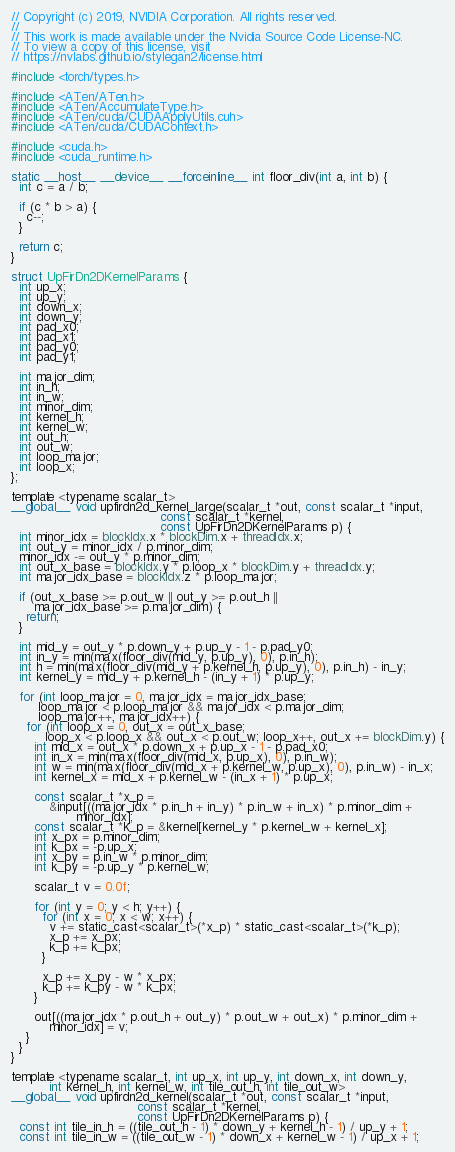Convert code to text. <code><loc_0><loc_0><loc_500><loc_500><_Cuda_>// Copyright (c) 2019, NVIDIA Corporation. All rights reserved.
//
// This work is made available under the Nvidia Source Code License-NC.
// To view a copy of this license, visit
// https://nvlabs.github.io/stylegan2/license.html

#include <torch/types.h>

#include <ATen/ATen.h>
#include <ATen/AccumulateType.h>
#include <ATen/cuda/CUDAApplyUtils.cuh>
#include <ATen/cuda/CUDAContext.h>

#include <cuda.h>
#include <cuda_runtime.h>

static __host__ __device__ __forceinline__ int floor_div(int a, int b) {
  int c = a / b;

  if (c * b > a) {
    c--;
  }

  return c;
}

struct UpFirDn2DKernelParams {
  int up_x;
  int up_y;
  int down_x;
  int down_y;
  int pad_x0;
  int pad_x1;
  int pad_y0;
  int pad_y1;

  int major_dim;
  int in_h;
  int in_w;
  int minor_dim;
  int kernel_h;
  int kernel_w;
  int out_h;
  int out_w;
  int loop_major;
  int loop_x;
};

template <typename scalar_t>
__global__ void upfirdn2d_kernel_large(scalar_t *out, const scalar_t *input,
                                       const scalar_t *kernel,
                                       const UpFirDn2DKernelParams p) {
  int minor_idx = blockIdx.x * blockDim.x + threadIdx.x;
  int out_y = minor_idx / p.minor_dim;
  minor_idx -= out_y * p.minor_dim;
  int out_x_base = blockIdx.y * p.loop_x * blockDim.y + threadIdx.y;
  int major_idx_base = blockIdx.z * p.loop_major;

  if (out_x_base >= p.out_w || out_y >= p.out_h ||
      major_idx_base >= p.major_dim) {
    return;
  }

  int mid_y = out_y * p.down_y + p.up_y - 1 - p.pad_y0;
  int in_y = min(max(floor_div(mid_y, p.up_y), 0), p.in_h);
  int h = min(max(floor_div(mid_y + p.kernel_h, p.up_y), 0), p.in_h) - in_y;
  int kernel_y = mid_y + p.kernel_h - (in_y + 1) * p.up_y;

  for (int loop_major = 0, major_idx = major_idx_base;
       loop_major < p.loop_major && major_idx < p.major_dim;
       loop_major++, major_idx++) {
    for (int loop_x = 0, out_x = out_x_base;
         loop_x < p.loop_x && out_x < p.out_w; loop_x++, out_x += blockDim.y) {
      int mid_x = out_x * p.down_x + p.up_x - 1 - p.pad_x0;
      int in_x = min(max(floor_div(mid_x, p.up_x), 0), p.in_w);
      int w = min(max(floor_div(mid_x + p.kernel_w, p.up_x), 0), p.in_w) - in_x;
      int kernel_x = mid_x + p.kernel_w - (in_x + 1) * p.up_x;

      const scalar_t *x_p =
          &input[((major_idx * p.in_h + in_y) * p.in_w + in_x) * p.minor_dim +
                 minor_idx];
      const scalar_t *k_p = &kernel[kernel_y * p.kernel_w + kernel_x];
      int x_px = p.minor_dim;
      int k_px = -p.up_x;
      int x_py = p.in_w * p.minor_dim;
      int k_py = -p.up_y * p.kernel_w;

      scalar_t v = 0.0f;

      for (int y = 0; y < h; y++) {
        for (int x = 0; x < w; x++) {
          v += static_cast<scalar_t>(*x_p) * static_cast<scalar_t>(*k_p);
          x_p += x_px;
          k_p += k_px;
        }

        x_p += x_py - w * x_px;
        k_p += k_py - w * k_px;
      }

      out[((major_idx * p.out_h + out_y) * p.out_w + out_x) * p.minor_dim +
          minor_idx] = v;
    }
  }
}

template <typename scalar_t, int up_x, int up_y, int down_x, int down_y,
          int kernel_h, int kernel_w, int tile_out_h, int tile_out_w>
__global__ void upfirdn2d_kernel(scalar_t *out, const scalar_t *input,
                                 const scalar_t *kernel,
                                 const UpFirDn2DKernelParams p) {
  const int tile_in_h = ((tile_out_h - 1) * down_y + kernel_h - 1) / up_y + 1;
  const int tile_in_w = ((tile_out_w - 1) * down_x + kernel_w - 1) / up_x + 1;
</code> 